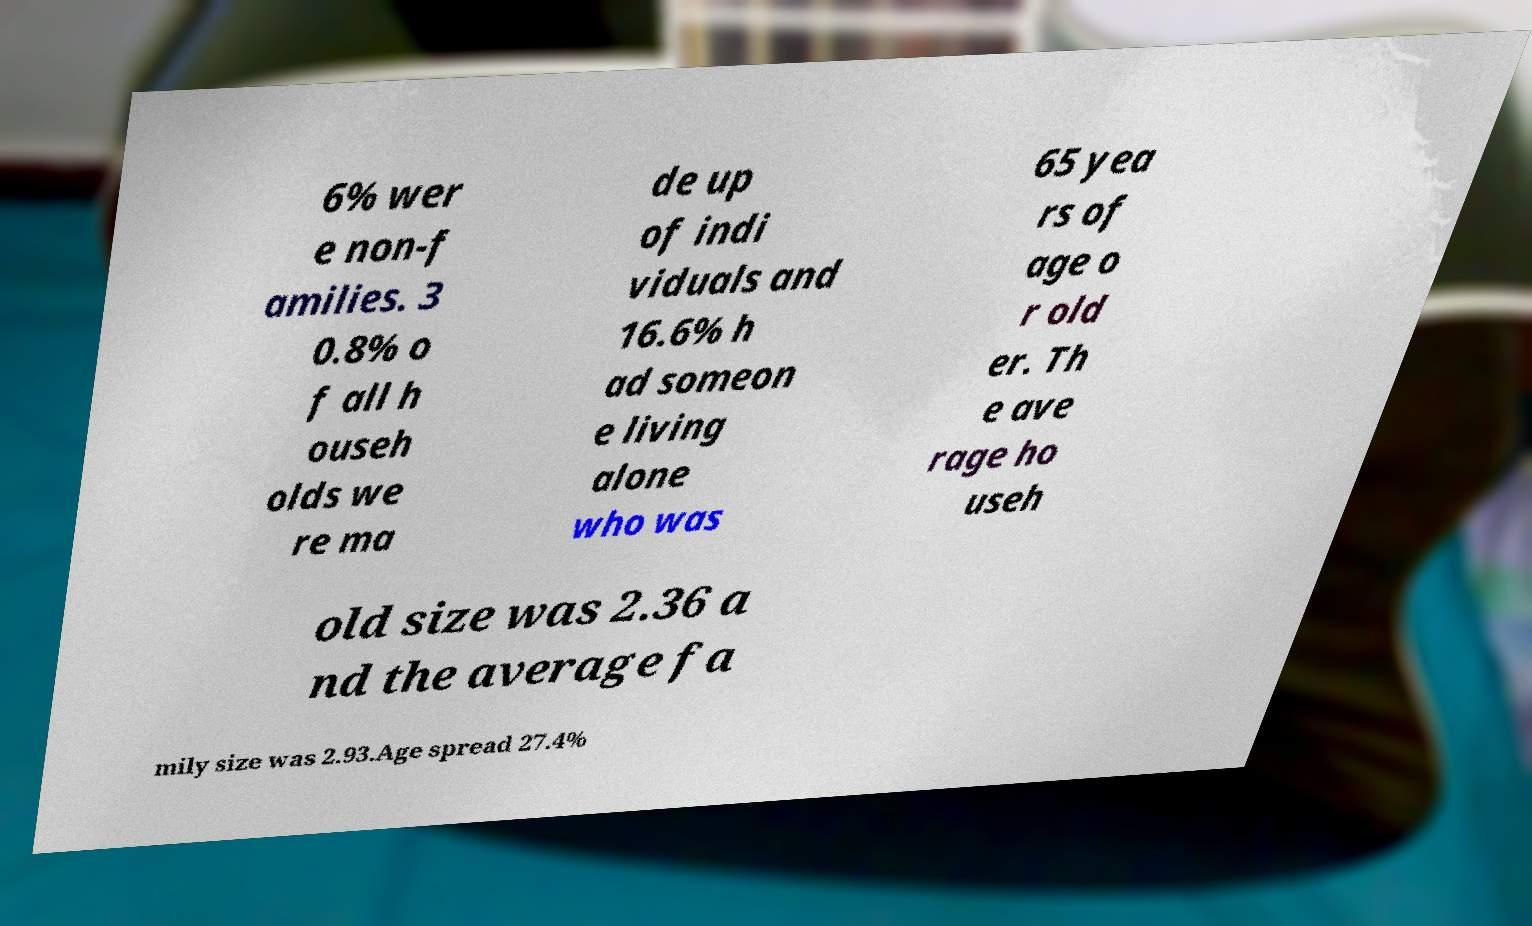I need the written content from this picture converted into text. Can you do that? 6% wer e non-f amilies. 3 0.8% o f all h ouseh olds we re ma de up of indi viduals and 16.6% h ad someon e living alone who was 65 yea rs of age o r old er. Th e ave rage ho useh old size was 2.36 a nd the average fa mily size was 2.93.Age spread 27.4% 